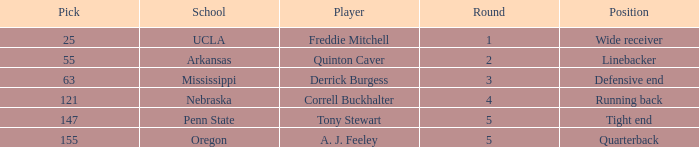What position did a. j. feeley play who was picked in round 5? Quarterback. 